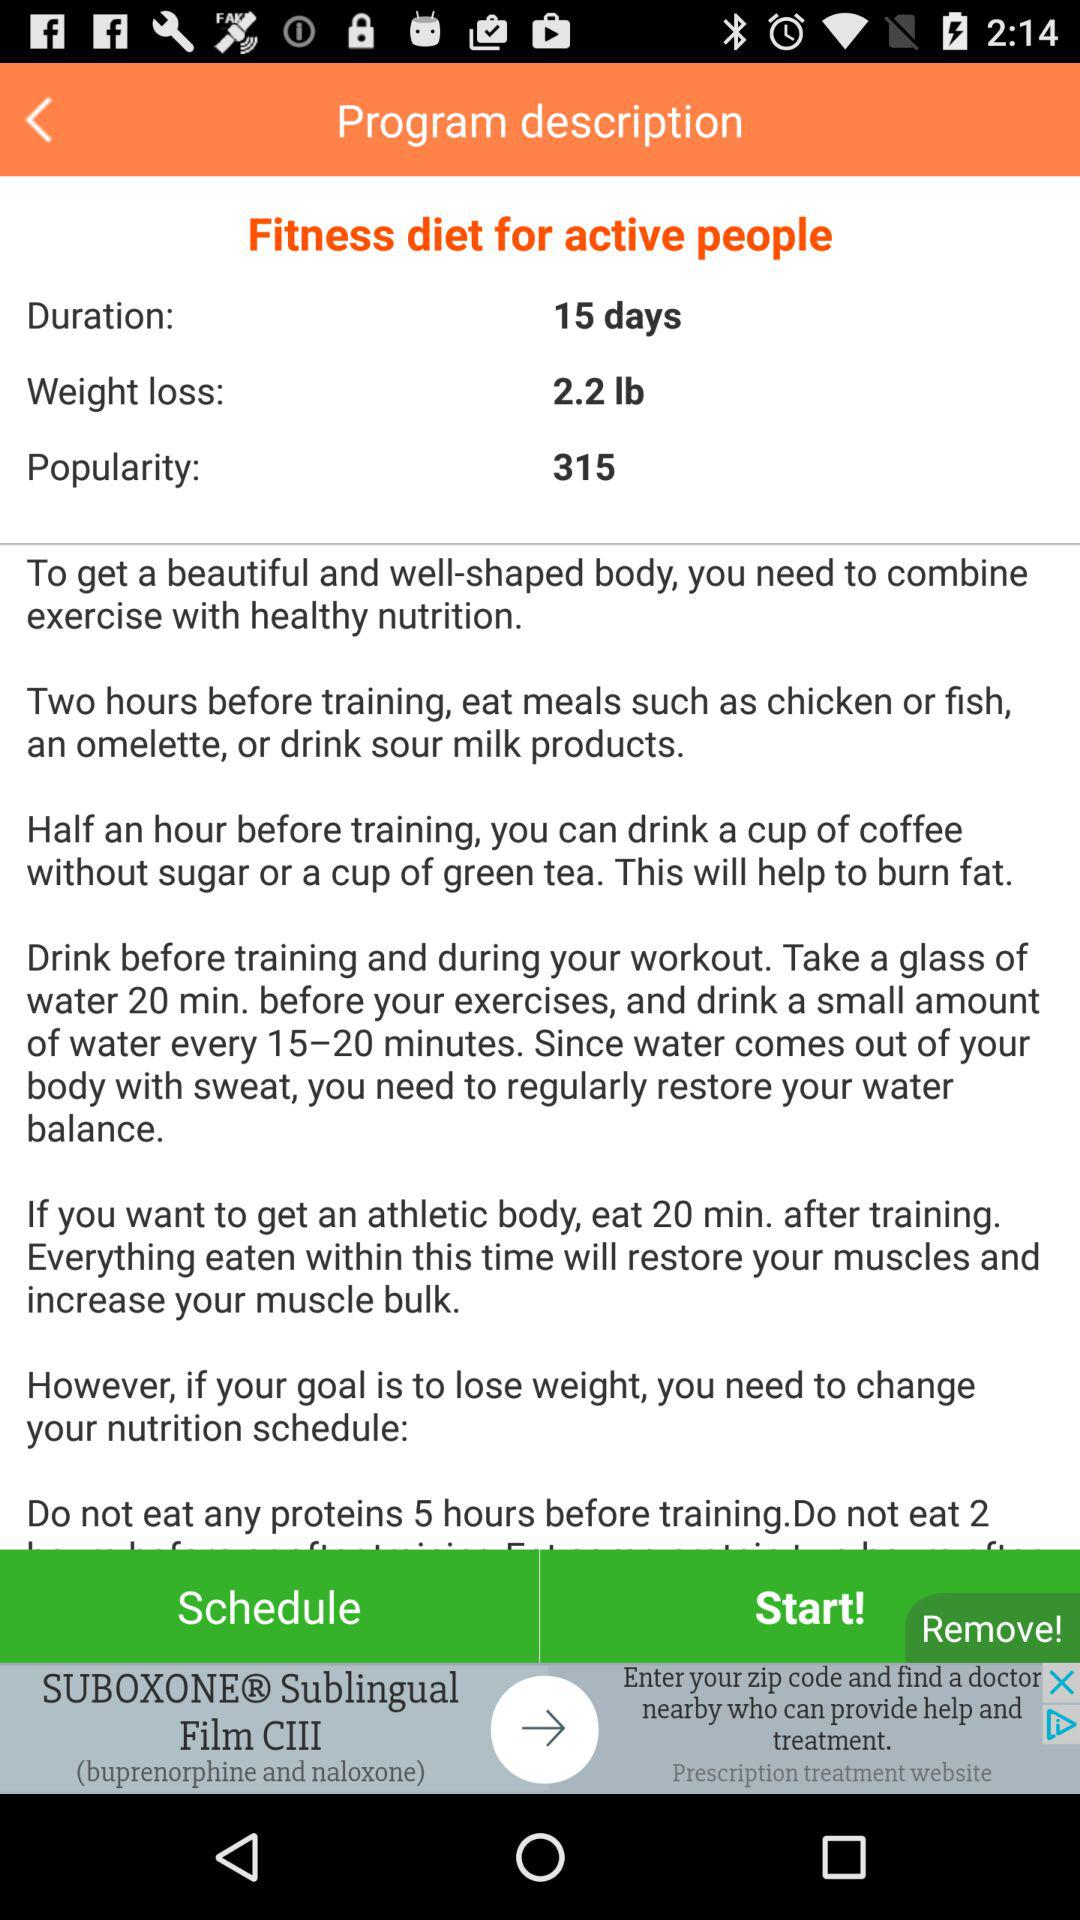What is the duration? The duration is 15 days. 